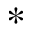Convert formula to latex. <formula><loc_0><loc_0><loc_500><loc_500>\ast</formula> 